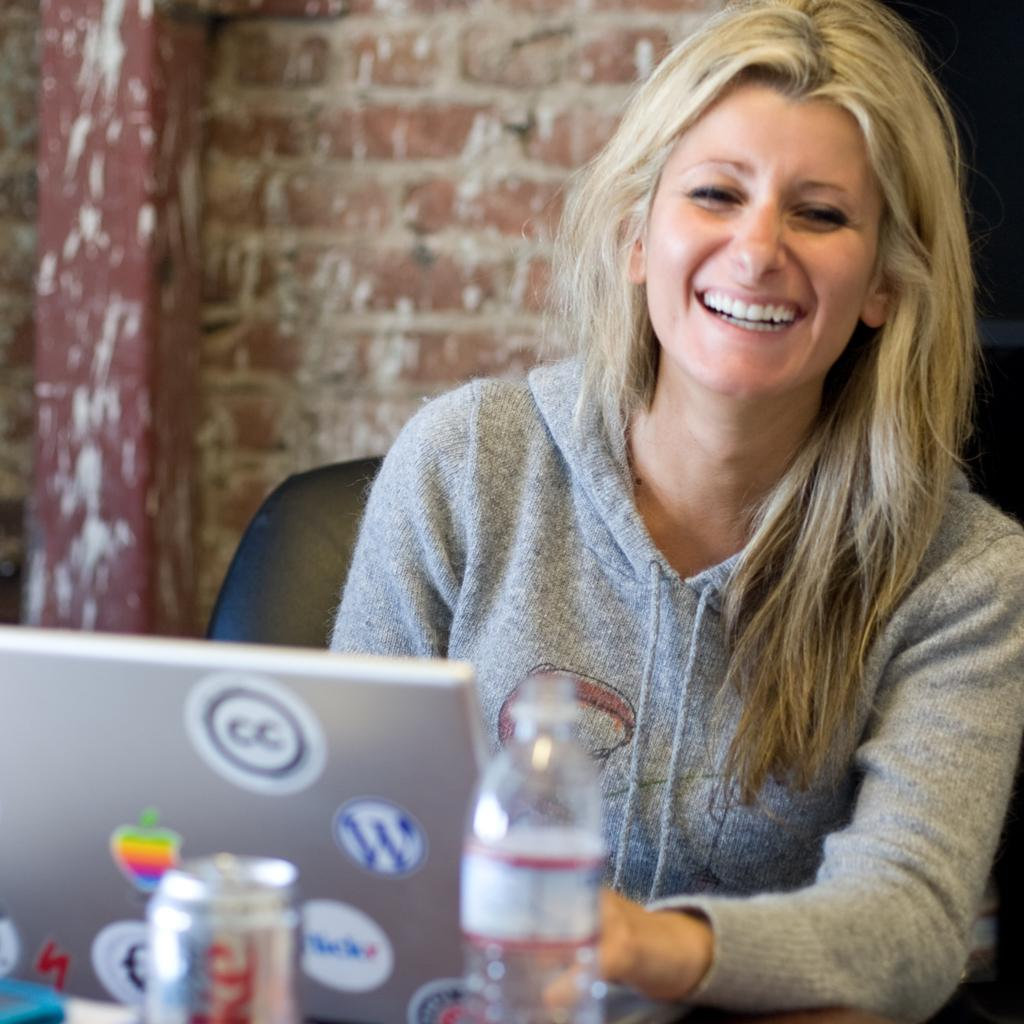Who is in the picture? There is a lady in the picture. What is the lady doing in the picture? The lady is sitting on a chair and smiling. What objects are in front of the lady? There is a laptop, a Coke can, and a water bottle in front of the lady. What can be seen in the background of the picture? There is a wall in the background of the picture. What type of hammer is the lady using in the picture? There is no hammer present in the image. What action is the lady performing in the picture? The lady is sitting on a chair and smiling, but there is no specific action being performed. 